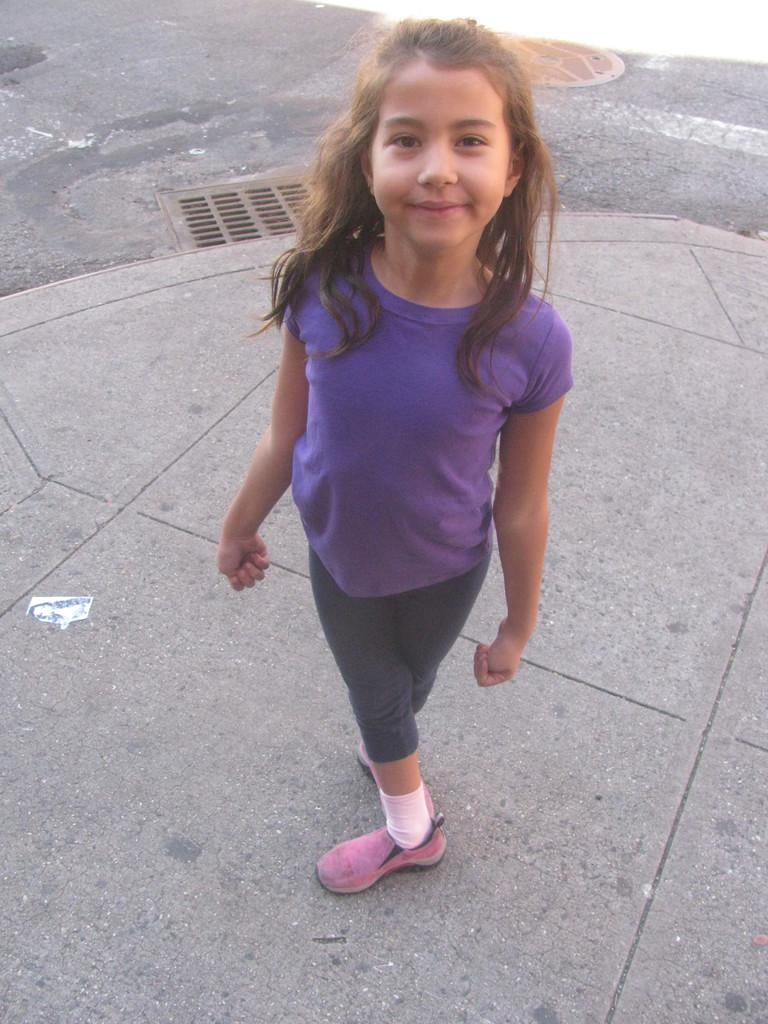Who is the main subject in the image? There is a girl in the image. What is the girl doing in the image? The girl is standing and smiling. What can be seen in the background of the image? There appears to be a manhole on the road in the background of the image. What type of bomb is being diffused by the girl in the image? There is no bomb present in the image; it features a girl standing and smiling. How does the girl plan to pull the manhole cover in the image? There is no indication in the image that the girl is attempting to pull the manhole cover, and it is not clear if she has the ability to do so. 